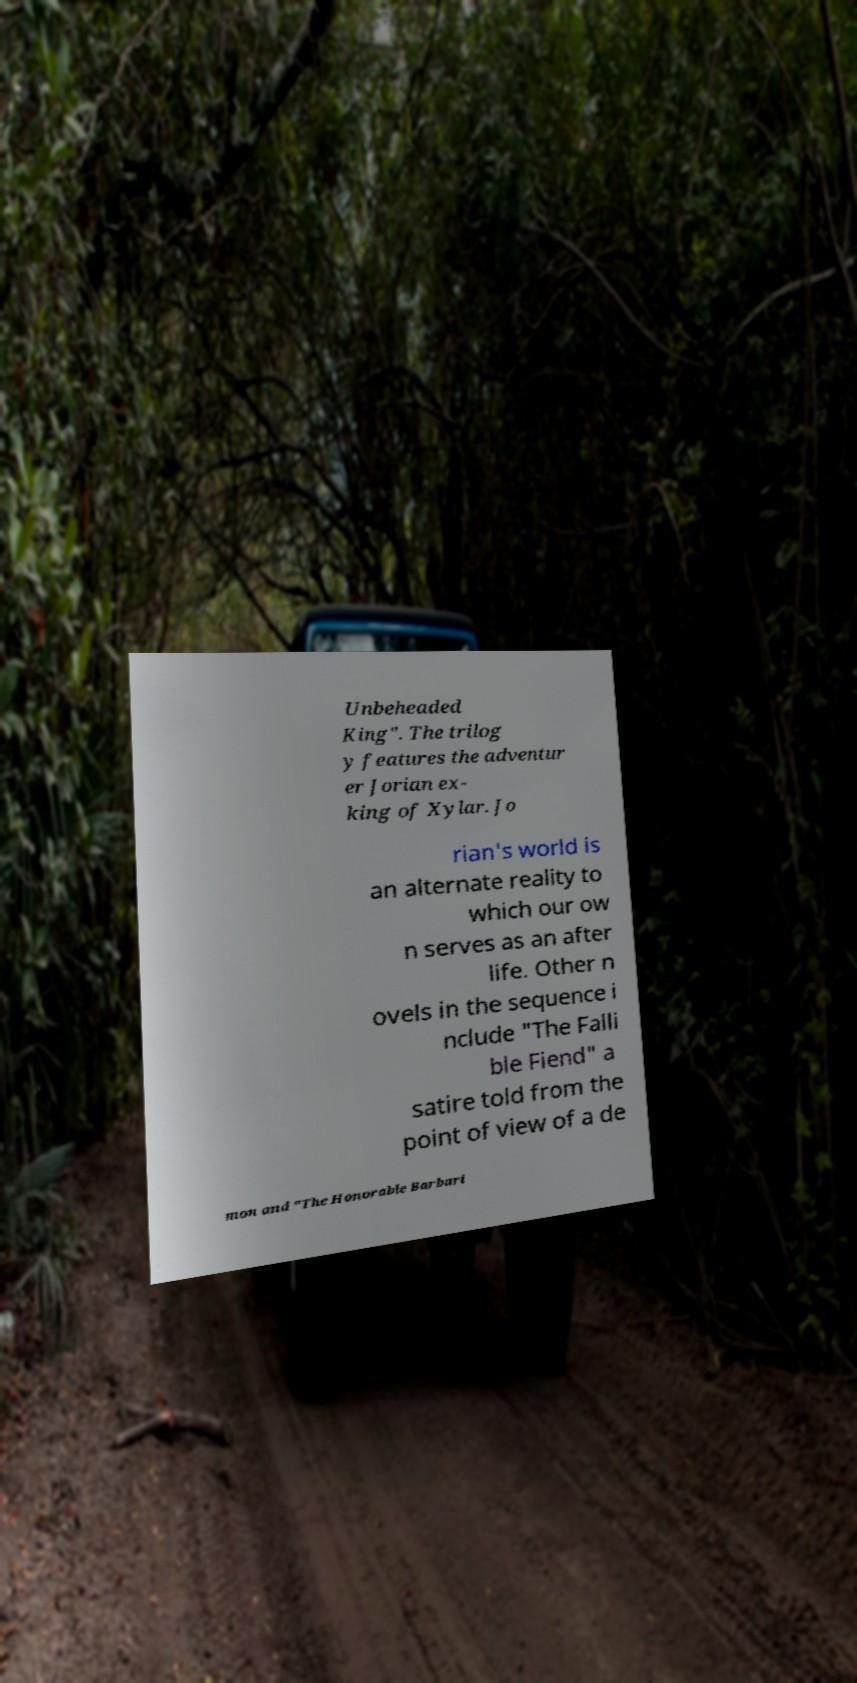For documentation purposes, I need the text within this image transcribed. Could you provide that? Unbeheaded King". The trilog y features the adventur er Jorian ex- king of Xylar. Jo rian's world is an alternate reality to which our ow n serves as an after life. Other n ovels in the sequence i nclude "The Falli ble Fiend" a satire told from the point of view of a de mon and "The Honorable Barbari 